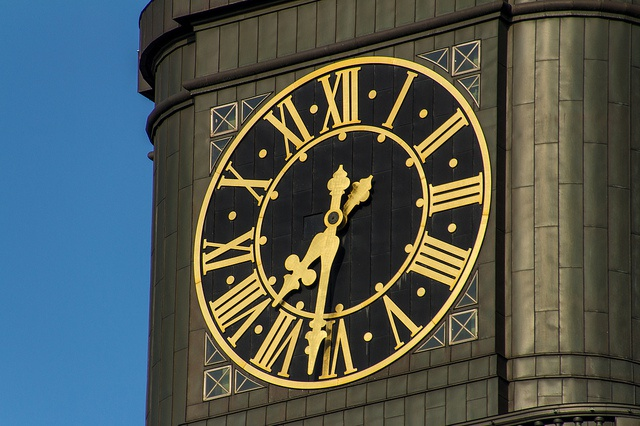Describe the objects in this image and their specific colors. I can see a clock in gray, black, khaki, tan, and olive tones in this image. 